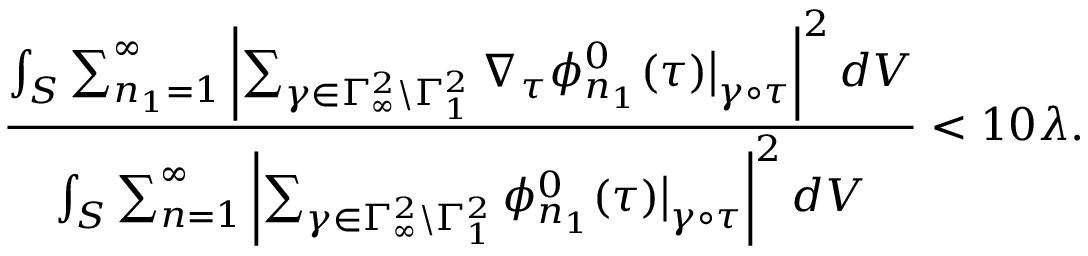Convert formula to latex. <formula><loc_0><loc_0><loc_500><loc_500>\frac { \int _ { S } \sum _ { n _ { 1 } = 1 } ^ { \infty } \left | \sum _ { \gamma \in \Gamma _ { \infty } ^ { 2 } \ \Gamma _ { 1 } ^ { 2 } } \nabla _ { \tau } \phi _ { n _ { 1 } } ^ { 0 } ( \tau ) \left | _ { \gamma \circ \tau } \right | ^ { 2 } d V } { \int _ { S } \sum _ { n = 1 } ^ { \infty } \left | \sum _ { \gamma \in \Gamma _ { \infty } ^ { 2 } \ \Gamma _ { 1 } ^ { 2 } } \phi _ { n _ { 1 } } ^ { 0 } ( \tau ) \right | _ { \gamma \circ \tau } \right | ^ { 2 } d V } < 1 0 \lambda .</formula> 